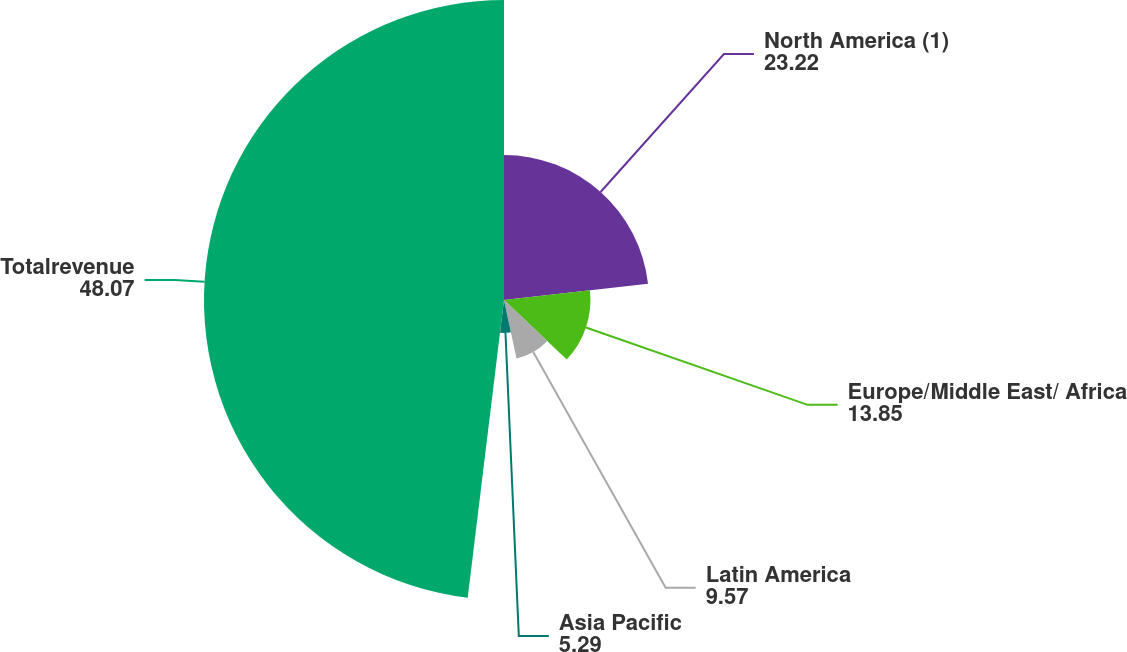Convert chart. <chart><loc_0><loc_0><loc_500><loc_500><pie_chart><fcel>North America (1)<fcel>Europe/Middle East/ Africa<fcel>Latin America<fcel>Asia Pacific<fcel>Totalrevenue<nl><fcel>23.22%<fcel>13.85%<fcel>9.57%<fcel>5.29%<fcel>48.07%<nl></chart> 